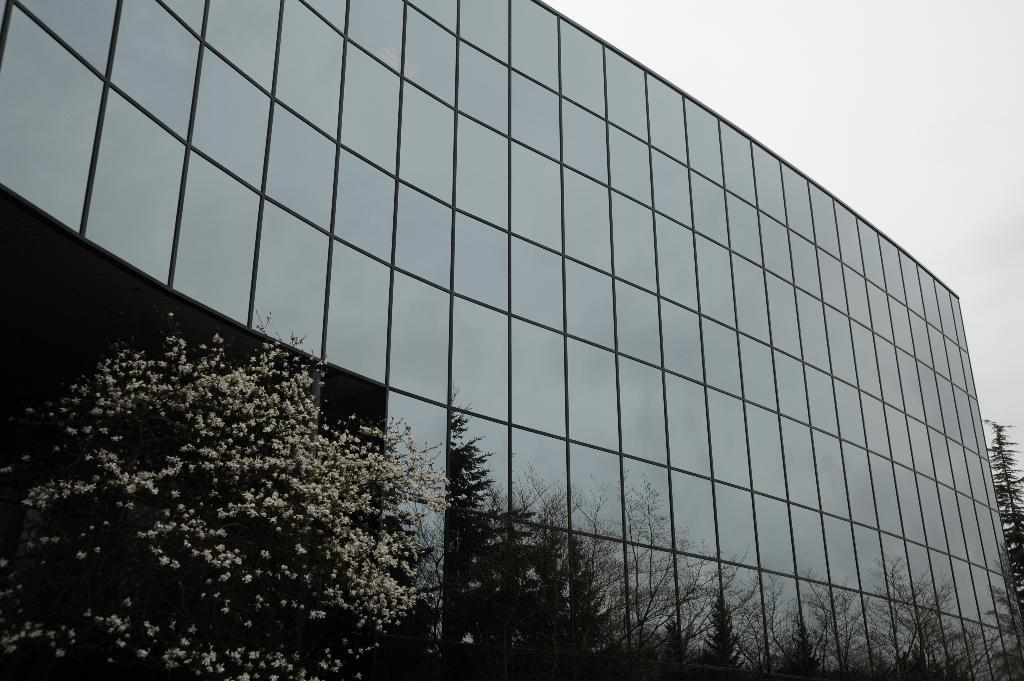What type of structure is present in the image? There is a building in the image. What is a notable feature of the building? The building has glass panels all over it. What can be seen in front of the building? There are trees in front of the building. What is visible above the building? The sky is visible above the building. What type of legal advice can be obtained from the building in the image? There is no indication in the image that the building is a law office or provides legal advice. 